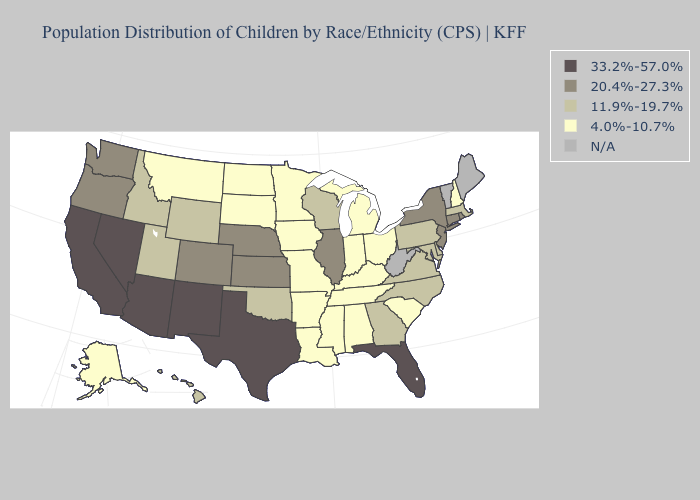Which states have the highest value in the USA?
Short answer required. Arizona, California, Florida, Nevada, New Mexico, Texas. Name the states that have a value in the range 20.4%-27.3%?
Quick response, please. Colorado, Connecticut, Illinois, Kansas, Nebraska, New Jersey, New York, Oregon, Rhode Island, Washington. Does the first symbol in the legend represent the smallest category?
Keep it brief. No. Does Alabama have the lowest value in the USA?
Write a very short answer. Yes. Does Colorado have the highest value in the West?
Short answer required. No. What is the value of Florida?
Concise answer only. 33.2%-57.0%. Does the map have missing data?
Quick response, please. Yes. What is the value of Rhode Island?
Write a very short answer. 20.4%-27.3%. What is the lowest value in the MidWest?
Short answer required. 4.0%-10.7%. What is the lowest value in the MidWest?
Short answer required. 4.0%-10.7%. Among the states that border Wisconsin , which have the lowest value?
Quick response, please. Iowa, Michigan, Minnesota. Which states have the lowest value in the USA?
Short answer required. Alabama, Alaska, Arkansas, Indiana, Iowa, Kentucky, Louisiana, Michigan, Minnesota, Mississippi, Missouri, Montana, New Hampshire, North Dakota, Ohio, South Carolina, South Dakota, Tennessee. Name the states that have a value in the range 11.9%-19.7%?
Write a very short answer. Delaware, Georgia, Hawaii, Idaho, Maryland, Massachusetts, North Carolina, Oklahoma, Pennsylvania, Utah, Virginia, Wisconsin, Wyoming. Which states have the lowest value in the West?
Write a very short answer. Alaska, Montana. Does South Dakota have the lowest value in the USA?
Quick response, please. Yes. 